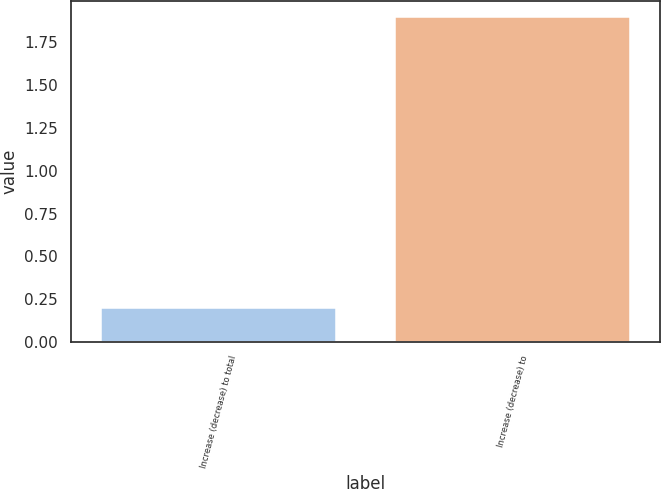Convert chart. <chart><loc_0><loc_0><loc_500><loc_500><bar_chart><fcel>Increase (decrease) to total<fcel>Increase (decrease) to<nl><fcel>0.2<fcel>1.9<nl></chart> 